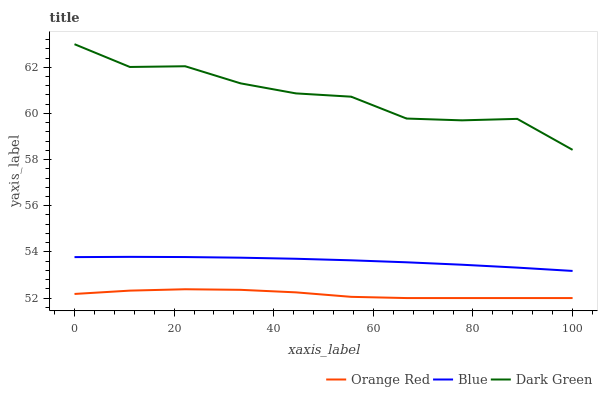Does Orange Red have the minimum area under the curve?
Answer yes or no. Yes. Does Dark Green have the maximum area under the curve?
Answer yes or no. Yes. Does Dark Green have the minimum area under the curve?
Answer yes or no. No. Does Orange Red have the maximum area under the curve?
Answer yes or no. No. Is Blue the smoothest?
Answer yes or no. Yes. Is Dark Green the roughest?
Answer yes or no. Yes. Is Orange Red the smoothest?
Answer yes or no. No. Is Orange Red the roughest?
Answer yes or no. No. Does Orange Red have the lowest value?
Answer yes or no. Yes. Does Dark Green have the lowest value?
Answer yes or no. No. Does Dark Green have the highest value?
Answer yes or no. Yes. Does Orange Red have the highest value?
Answer yes or no. No. Is Orange Red less than Dark Green?
Answer yes or no. Yes. Is Blue greater than Orange Red?
Answer yes or no. Yes. Does Orange Red intersect Dark Green?
Answer yes or no. No. 